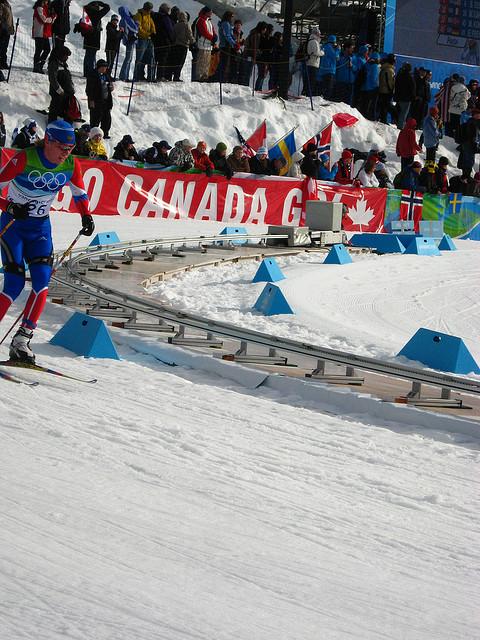IS there snow?
Write a very short answer. Yes. How many white circles are on the skiers shirt?
Short answer required. 5. Is this a competition?
Keep it brief. Yes. 